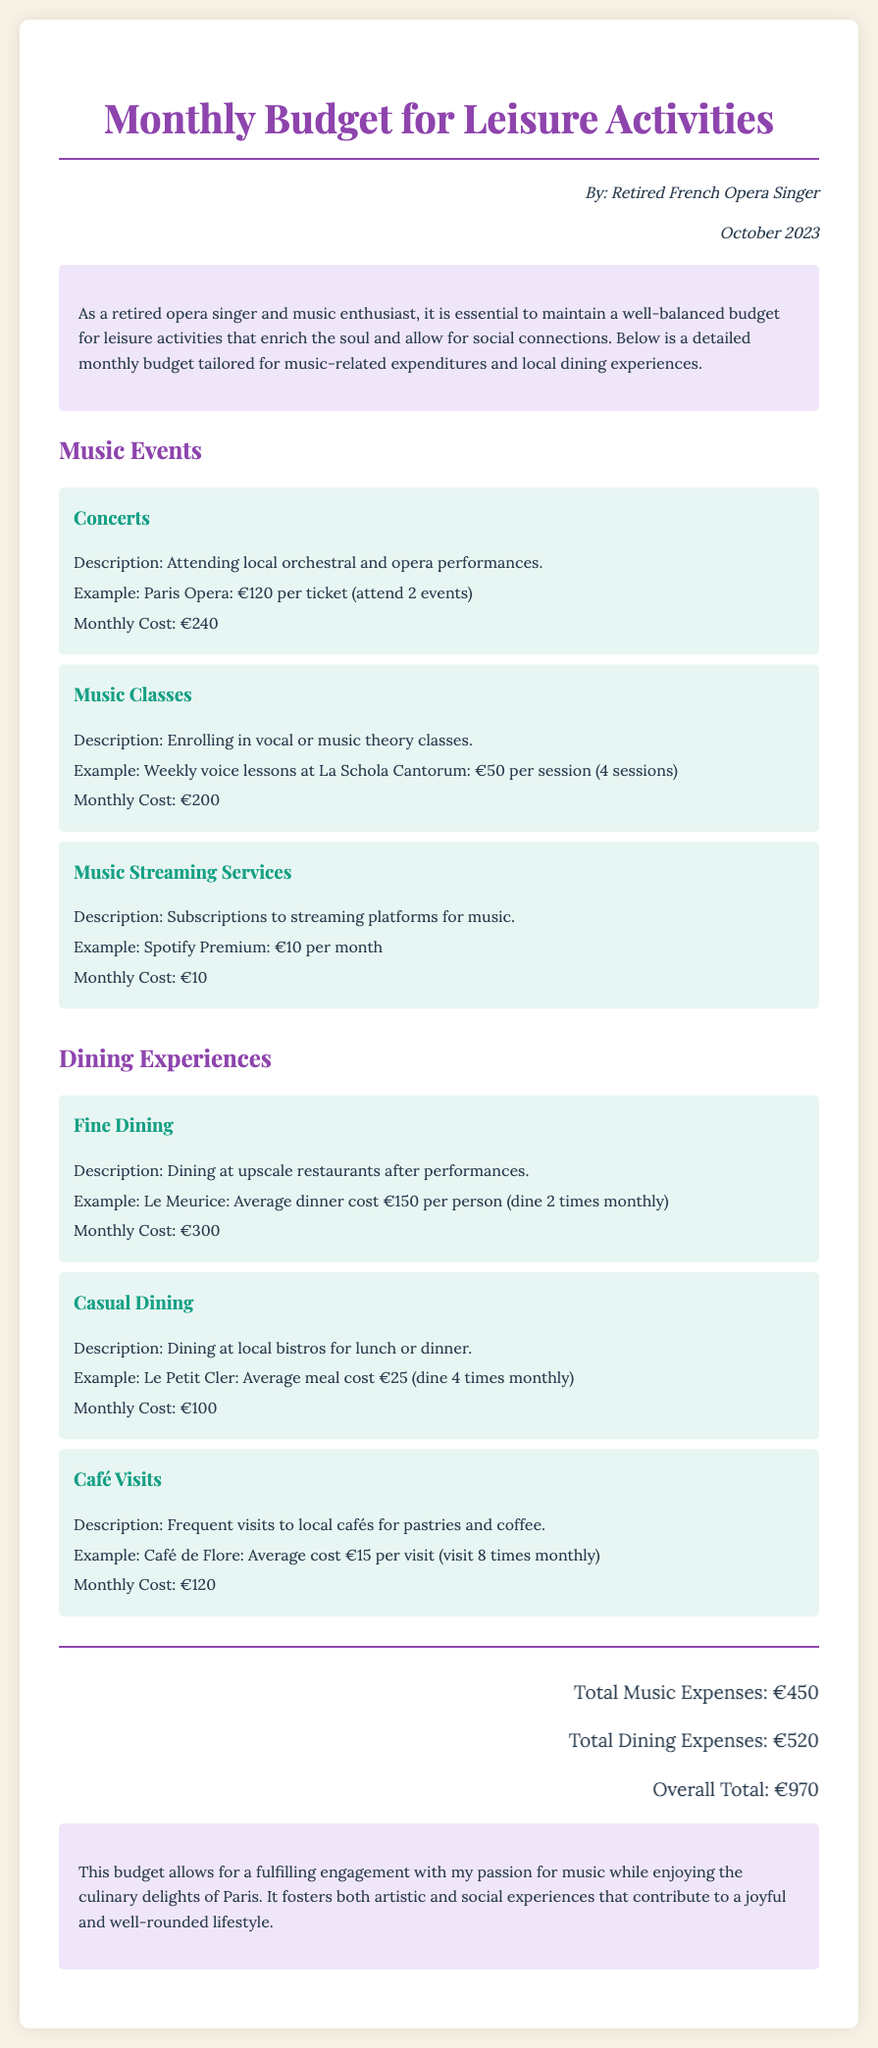what is the total monthly budget for leisure activities? The overall total is the sum of music and dining expenses, which is €450 + €520 = €970.
Answer: €970 how much is allocated for concerts? The budget item for concerts mentions attending 2 events at €120 per ticket.
Answer: €240 what is the average meal cost for casual dining? The document states that the average meal cost for casual dining at Le Petit Cler is €25.
Answer: €25 how many times is fine dining planned in the month? The memo indicates dining at Le Meurice two times monthly.
Answer: 2 times what is the monthly cost for music streaming services? The document specifies that the monthly cost for Spotify Premium is €10.
Answer: €10 what is the total for dining experiences? The total dining expenses are the sum of all dining categories: €300 (fine dining) + €100 (casual dining) + €120 (café visits) = €520.
Answer: €520 how many music classes are attended monthly? The document mentions enrolling in 4 weekly voice lessons at La Schola Cantorum.
Answer: 4 sessions what is the total for music events? The total music expenses are calculated as €240 (concerts) + €200 (music classes) + €10 (music streaming services) = €450.
Answer: €450 who authored the memo? The memo lists the author as a Retired French Opera Singer.
Answer: Retired French Opera Singer 